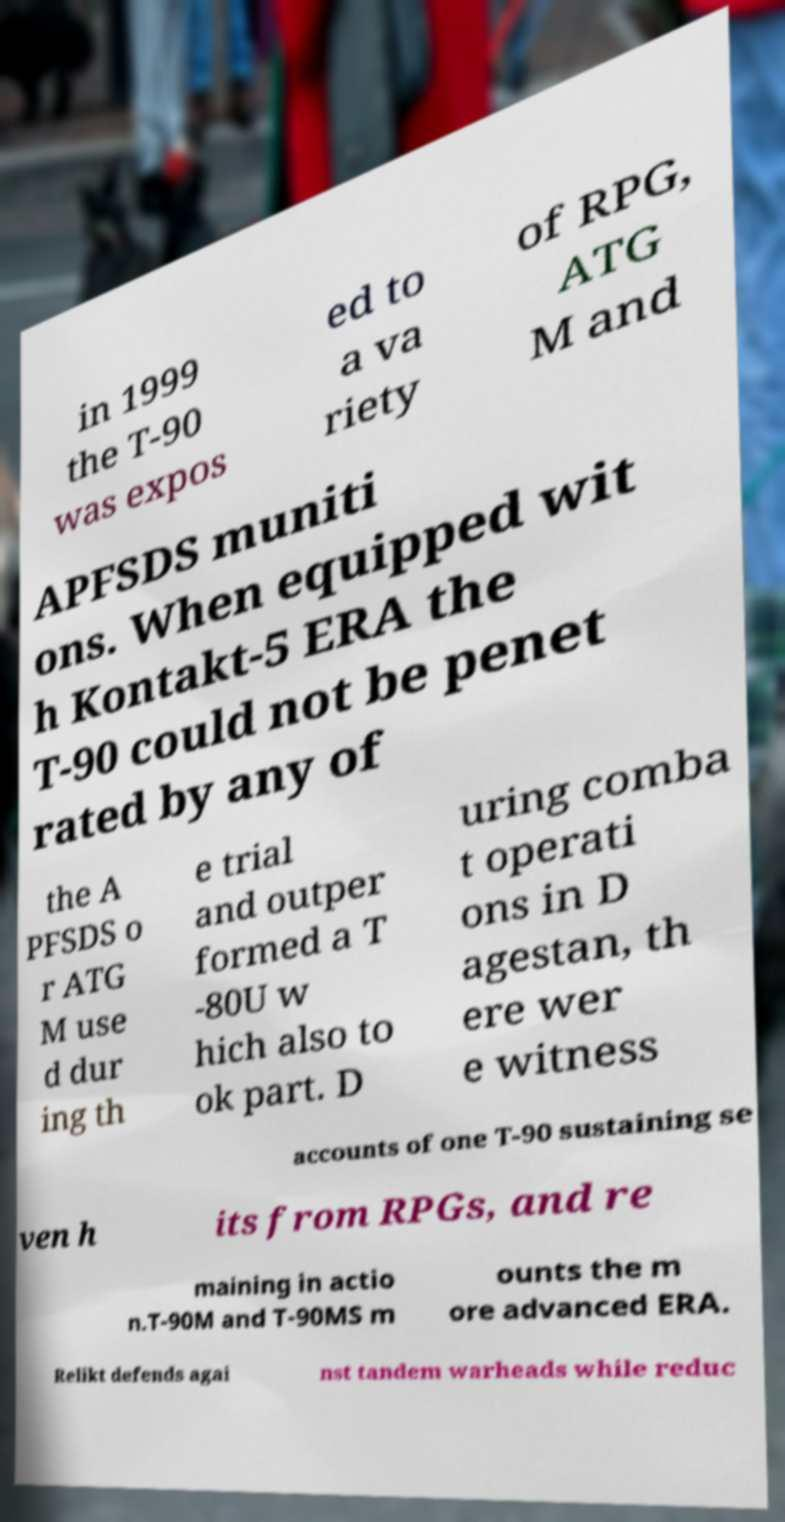Could you extract and type out the text from this image? in 1999 the T-90 was expos ed to a va riety of RPG, ATG M and APFSDS muniti ons. When equipped wit h Kontakt-5 ERA the T-90 could not be penet rated by any of the A PFSDS o r ATG M use d dur ing th e trial and outper formed a T -80U w hich also to ok part. D uring comba t operati ons in D agestan, th ere wer e witness accounts of one T-90 sustaining se ven h its from RPGs, and re maining in actio n.T-90M and T-90MS m ounts the m ore advanced ERA. Relikt defends agai nst tandem warheads while reduc 